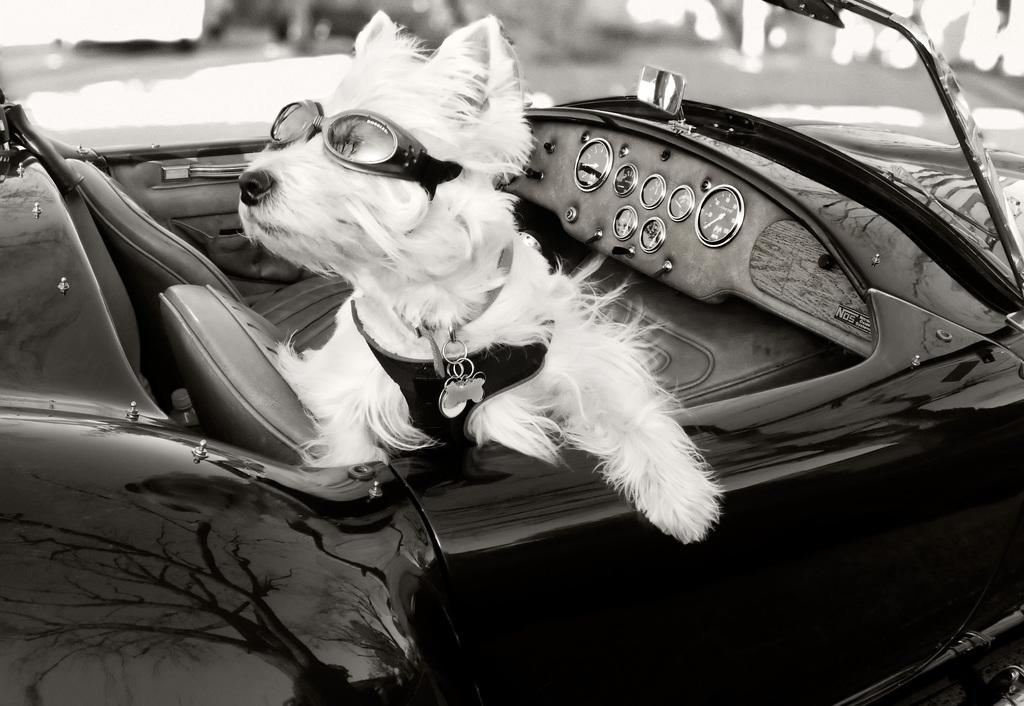What animal can be seen in the image? There is a dog in the image. Where is the dog located? The dog is sitting in a car. How many icicles are hanging from the dog's ears in the image? There are no icicles present in the image, as it features a dog sitting in a car. 